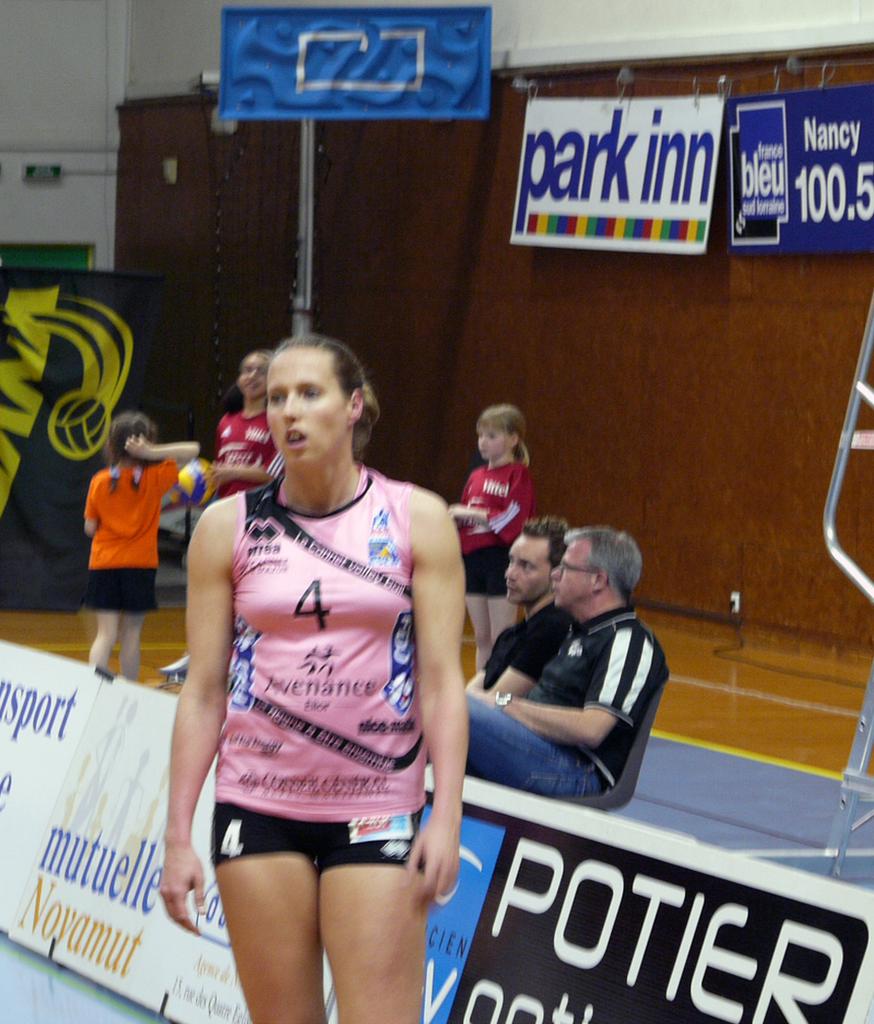What number is the girl in the pink shirt?
Your answer should be compact. 4. What is the sponsor on the white sign with the rainbow stripe on it?
Your response must be concise. Park inn. 